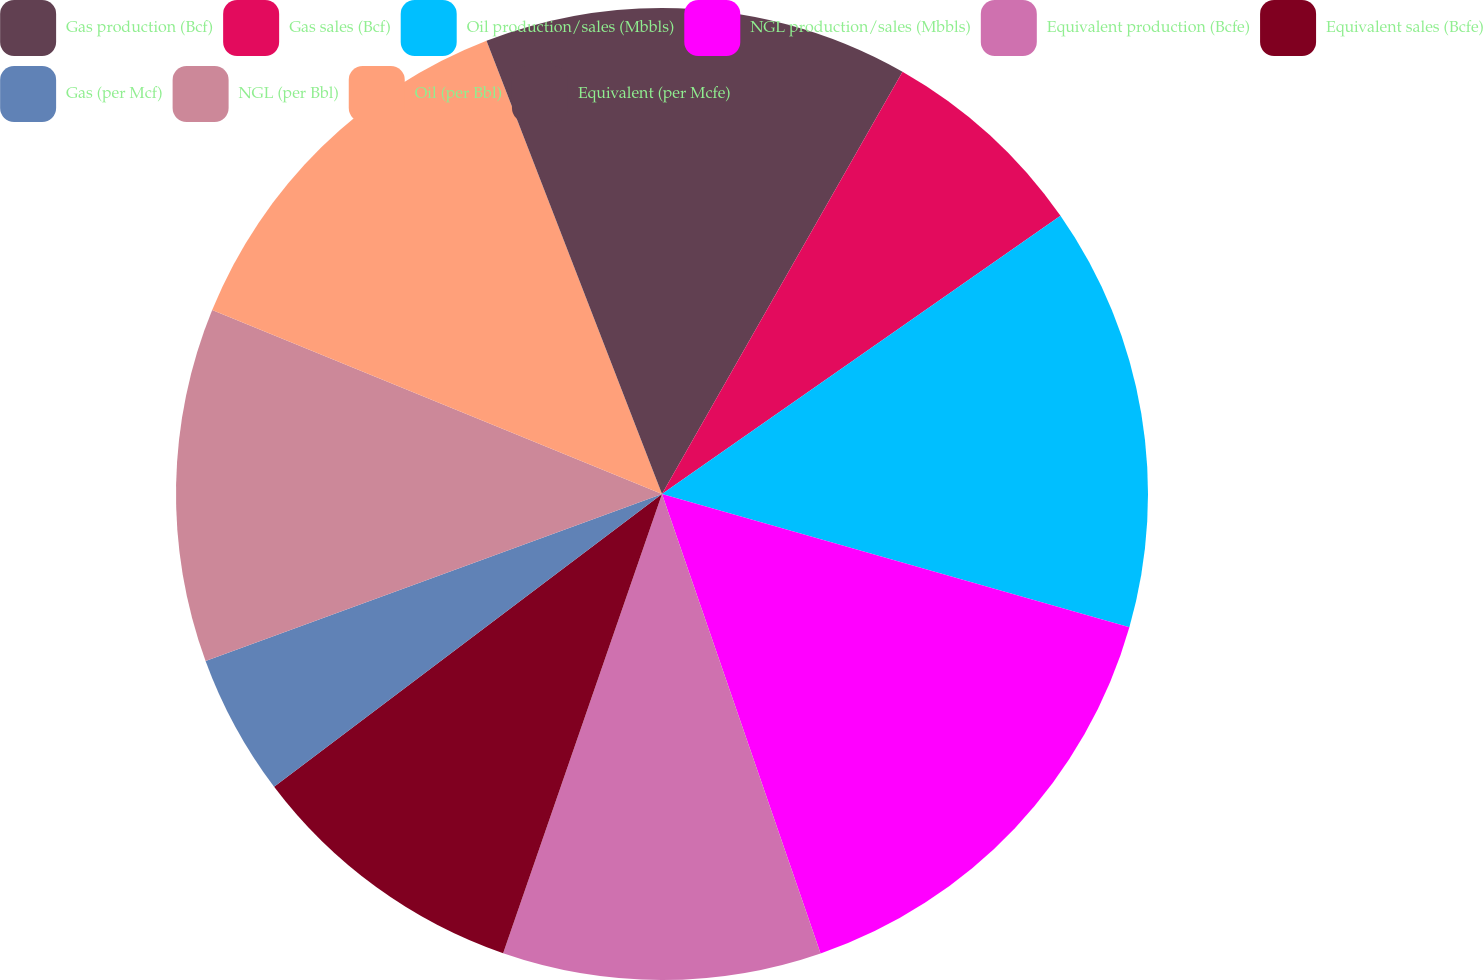Convert chart. <chart><loc_0><loc_0><loc_500><loc_500><pie_chart><fcel>Gas production (Bcf)<fcel>Gas sales (Bcf)<fcel>Oil production/sales (Mbbls)<fcel>NGL production/sales (Mbbls)<fcel>Equivalent production (Bcfe)<fcel>Equivalent sales (Bcfe)<fcel>Gas (per Mcf)<fcel>NGL (per Bbl)<fcel>Oil (per Bbl)<fcel>Equivalent (per Mcfe)<nl><fcel>8.24%<fcel>7.06%<fcel>14.12%<fcel>15.29%<fcel>10.59%<fcel>9.41%<fcel>4.71%<fcel>11.76%<fcel>12.94%<fcel>5.88%<nl></chart> 